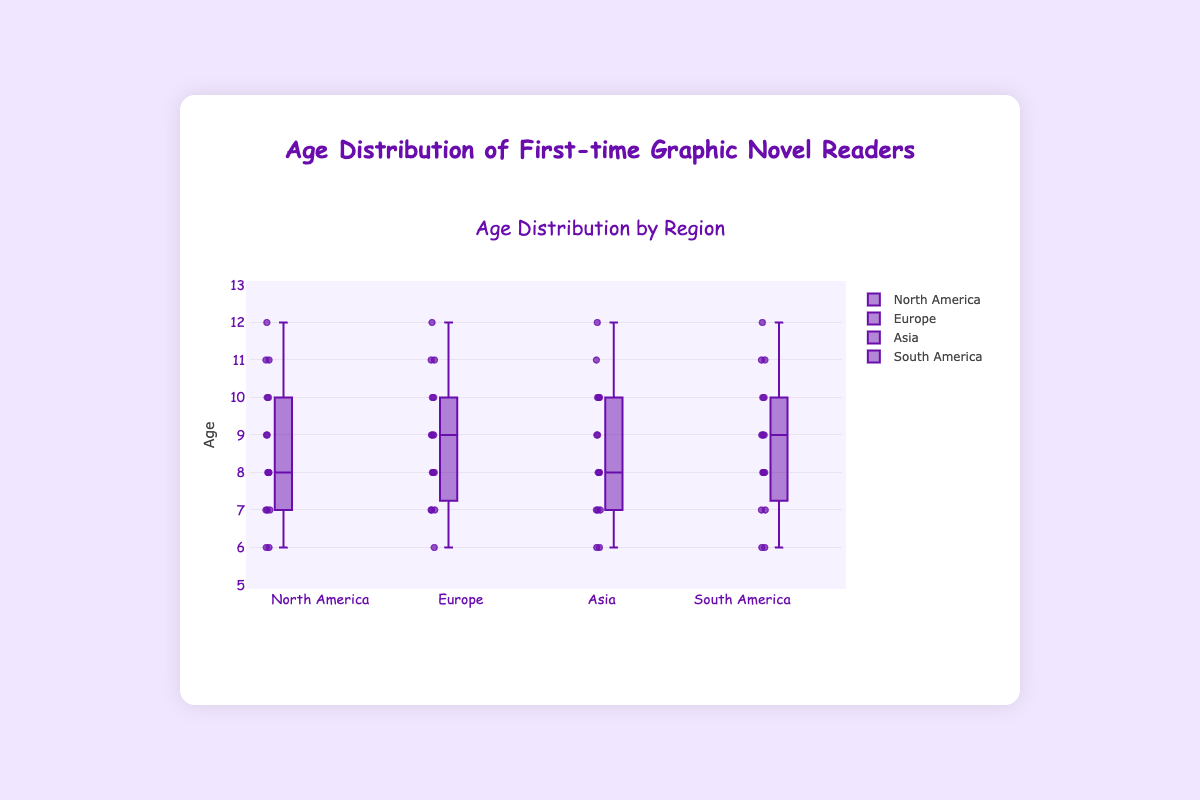What is the title of the figure? The title of the figure is found at the top center of the chart. It reads "Age Distribution by Region" in the figure.
Answer: Age Distribution by Region Which region has the youngest first-time graphic novel reader? By looking at the box plots, the lowest point in the box plot will represent the youngest reader. In this case, North America and South America both have their youngest readers at age 6.
Answer: North America and South America What is the median age of first-time graphic novel readers in Europe? To find the median age, look for the middle line inside the box for the Europe region. The median age for Europe readers is 9.
Answer: 9 Which region shows the widest age range for first-time graphic novel readers? The age range can be determined by looking at the distance between the minimum and maximum points (whiskers) of each box plot. South America has the widest range from 6 to 12.
Answer: South America Which two regions have the same interquartile range (IQR)? The IQR is the distance between the first quartile (Q1) and third quartile (Q3) of the box. North America and South America both have an IQR from 7 to 10.
Answer: North America and South America Which region has the highest median age for first-time graphic novel readers? The highest median can be found by looking at the middle line of each box plot and comparing their positions. South America has the highest median age of 9.
Answer: South America What is the third quartile (Q3) of the age distribution in Asia? The third quartile is the upper line of the box, which represents the 75th percentile. For Asia, Q3 is 10.
Answer: 10 Which region has the lowest median age for first-time graphic novel readers? Compare the middle lines inside the boxes for all regions. North America and Europe share the lowest median age of 8.
Answer: North America and Europe What is the age range for first-time graphic novel readers in Asia? The age range is the difference between the maximum and minimum ages. For Asia, the minimum age is 6 and the maximum age is 12.
Answer: 6-12 How does the age distribution in Europe compare to North America? Compare the median lines and the spread of ages (range and IQR). Europe has a similar median age (8 vs 9) and IQR (7-10) as North America but a different overall age range.
Answer: Similar median and IQR, different range 